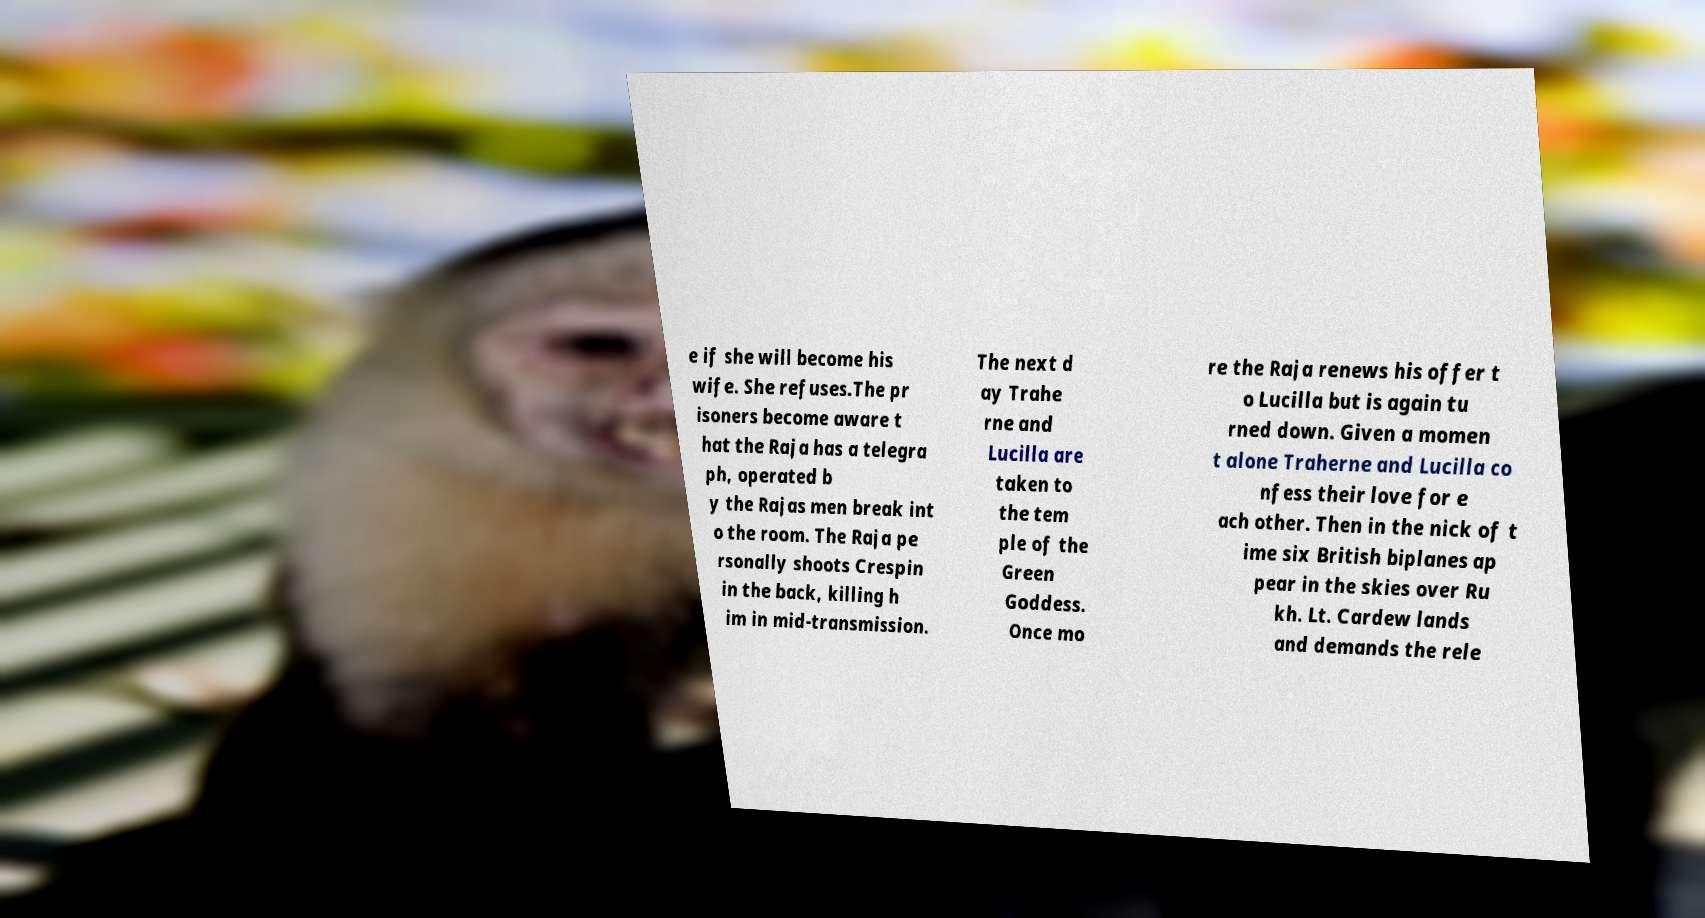Could you extract and type out the text from this image? e if she will become his wife. She refuses.The pr isoners become aware t hat the Raja has a telegra ph, operated b y the Rajas men break int o the room. The Raja pe rsonally shoots Crespin in the back, killing h im in mid-transmission. The next d ay Trahe rne and Lucilla are taken to the tem ple of the Green Goddess. Once mo re the Raja renews his offer t o Lucilla but is again tu rned down. Given a momen t alone Traherne and Lucilla co nfess their love for e ach other. Then in the nick of t ime six British biplanes ap pear in the skies over Ru kh. Lt. Cardew lands and demands the rele 